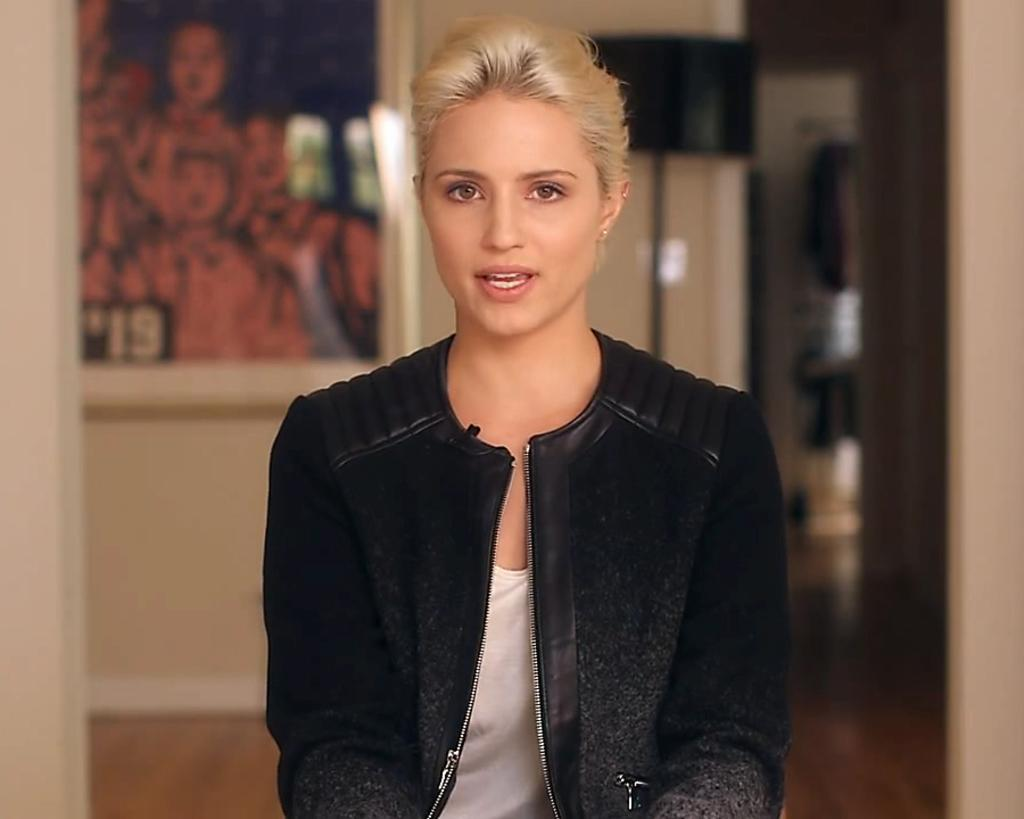Who is the main subject in the foreground of the image? There is a woman in the foreground of the image. What is the woman's position in the image? The woman is on the floor. What can be seen in the foreground of the image besides the woman? There is a door in the foreground of the image. What is visible in the background of the image? There is a photo frame on a wall and other objects in the background of the image. Can you describe the person in the background of the image? There is a person in the background of the image, but no specific details are provided. What type of location is suggested by the presence of a door and a wall in the image? The image is likely taken in a room. What type of basket is the woman carrying in the image? There is no basket present in the image. How does the woman express her feelings of hate in the image? The image does not show any expression of hate or any emotions from the woman. 